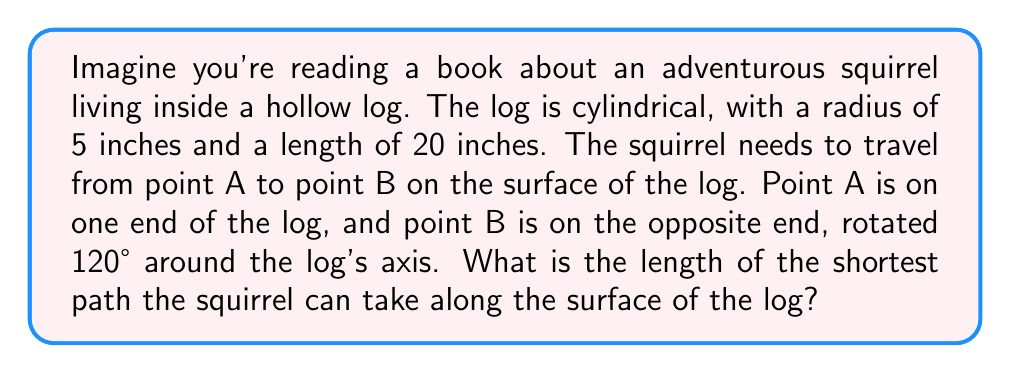Provide a solution to this math problem. Let's approach this problem step-by-step:

1) First, we need to visualize the problem. The cylinder can be "unrolled" into a rectangle, where the circumference of the cylinder becomes the width of the rectangle, and the length of the cylinder becomes the height of the rectangle.

2) The circumference of the base of the cylinder is:
   $$C = 2\pi r = 2\pi(5) = 10\pi \text{ inches}$$

3) Now, we can represent the problem on a 2D plane:

[asy]
import geometry;

size(200);
draw((0,0)--(10*pi,0)--(10*pi,20)--(0,20)--cycle);
dot((0,0),red);
dot((8*pi,20),red);
label("A",(0,0),SW);
label("B",(8*pi,20),NE);
draw((0,0)--(8*pi,20),blue);
[/asy]

4) In this representation, point A is at (0,0) and point B is at $(8\pi, 20)$. The 120° rotation translates to $\frac{120}{360} = \frac{1}{3}$ of the circumference, which is $\frac{1}{3}(10\pi) = \frac{10\pi}{3}$.

5) The shortest path between these points is a straight line. We can find its length using the distance formula:

   $$d = \sqrt{(\Delta x)^2 + (\Delta y)^2}$$

6) Plugging in our values:

   $$d = \sqrt{(\frac{10\pi}{3})^2 + 20^2}$$

7) Simplifying:

   $$d = \sqrt{\frac{100\pi^2}{9} + 400}$$

8) This can be further simplified to:

   $$d = \sqrt{\frac{100\pi^2 + 3600}{9}}$$

9) Taking the square root:

   $$d = \frac{\sqrt{100\pi^2 + 3600}}{3} \text{ inches}$$

This is the length of the shortest path on the surface of the log.
Answer: The length of the shortest path is $\frac{\sqrt{100\pi^2 + 3600}}{3}$ inches, or approximately 22.31 inches. 